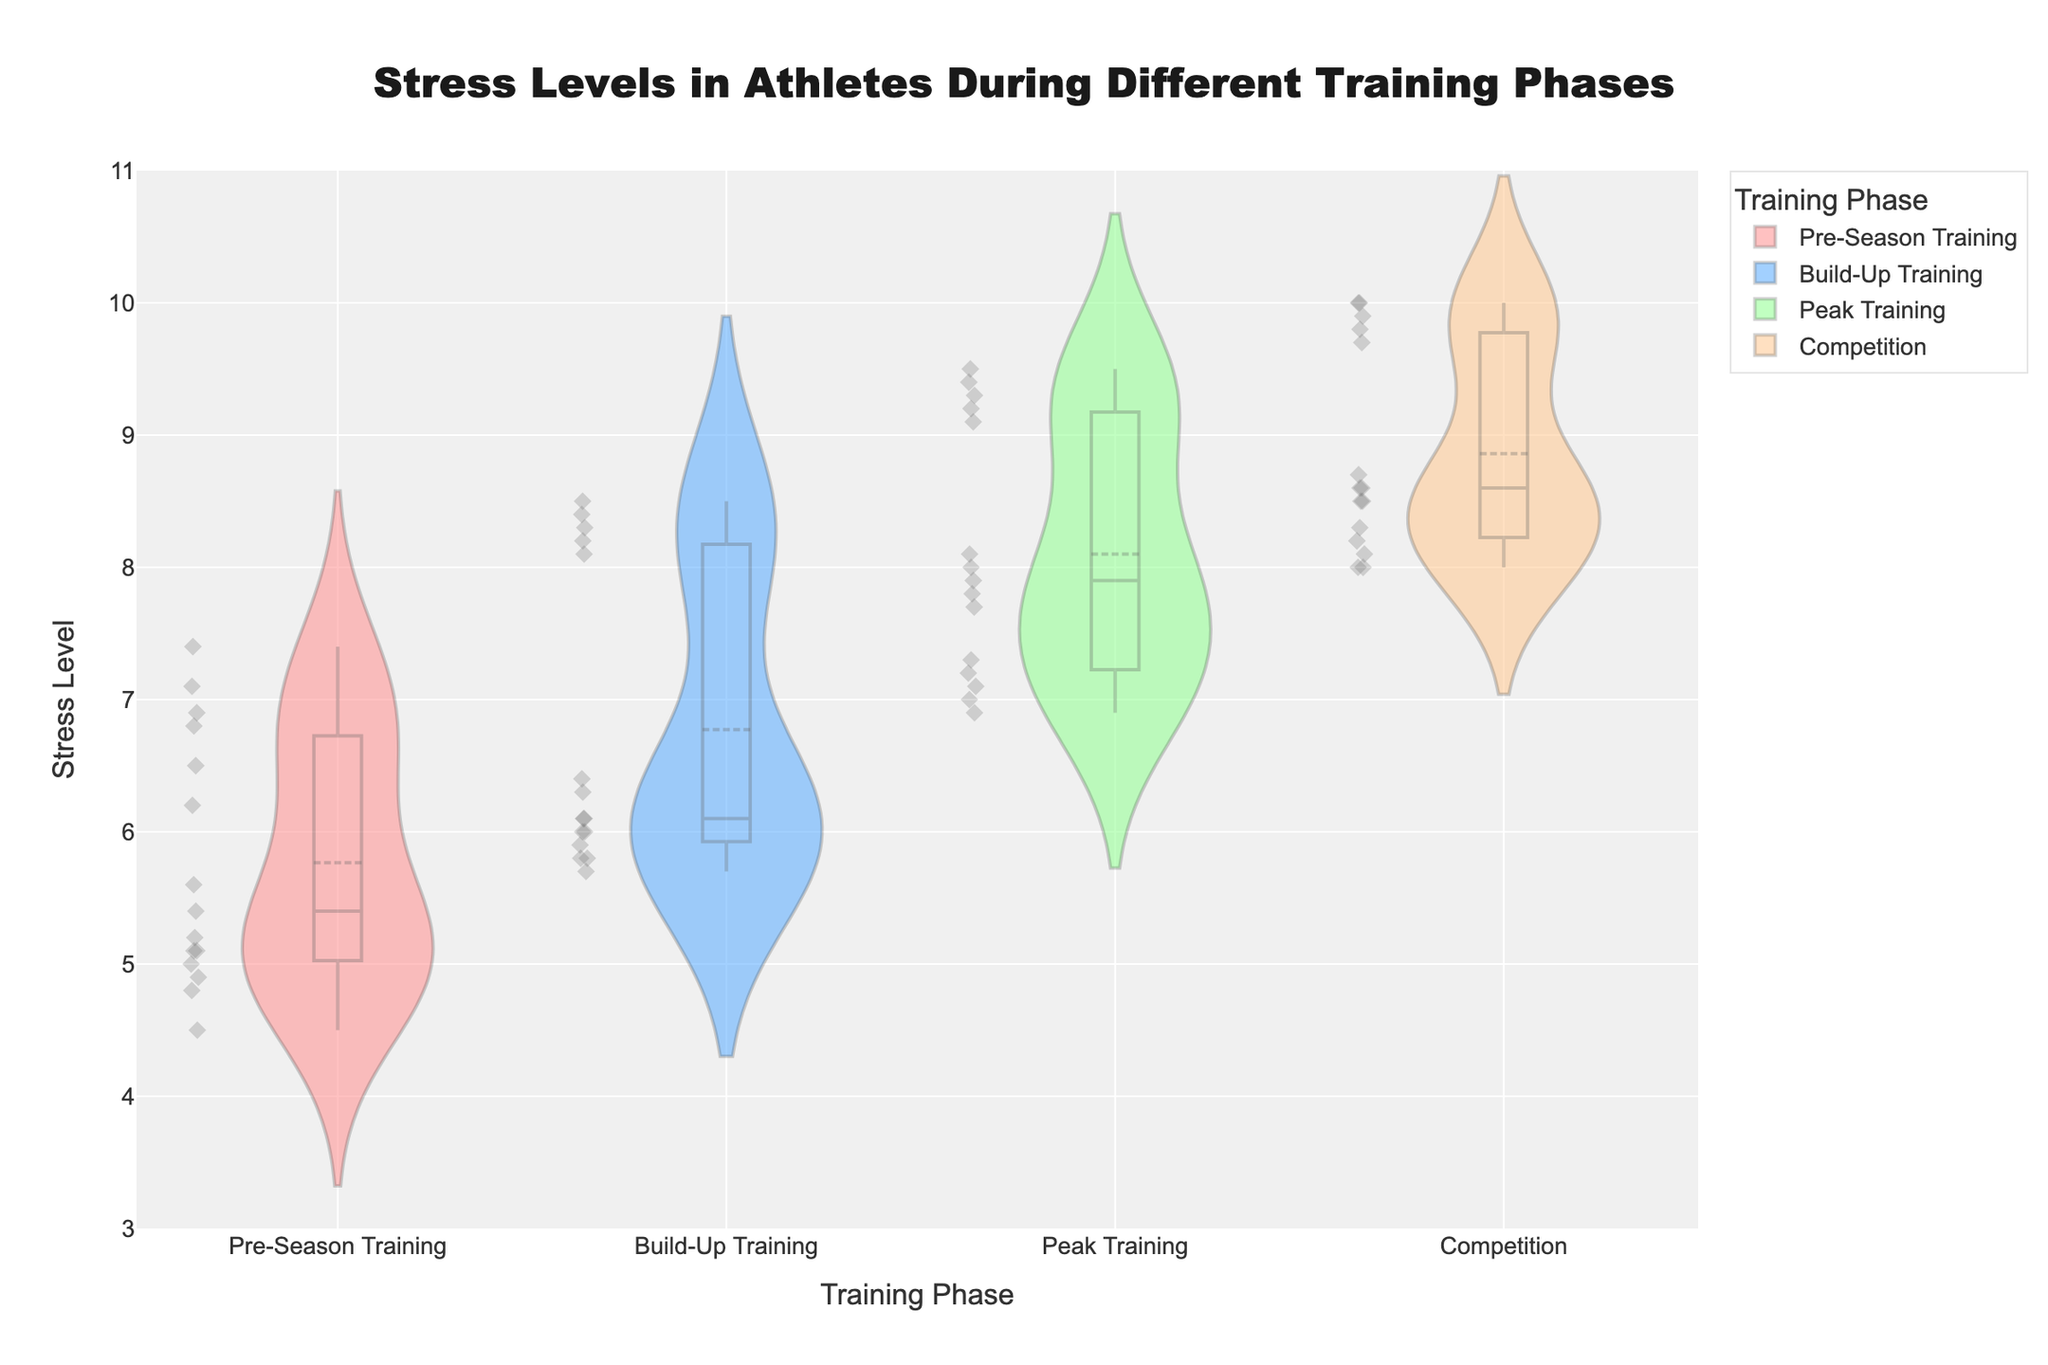What are the phases of training shown in the title of the plot? The title of the plot lists "Stress Levels in Athletes During Different Training Phases". The phases of training on the x-axis of the plot are "Pre-Season Training", "Build-Up Training", "Peak Training", and "Competition".
Answer: Pre-Season Training, Build-Up Training, Peak Training, Competition What is the maximum stress level for James Duncan during the Competition phase? Look at the violin plot for James Duncan during the Competition phase, which includes both the distribution and individual points. The highest data point is at 10.0.
Answer: 10.0 Which phase has the lowest median stress level for Maria Stepanova? Examine the box plots within each violin plot for Maria Stepanova across all phases. The box plot indicates the median as a line. The lowest median is seen in "Pre-Season Training".
Answer: Pre-Season Training Which phase shows the highest average stress level for Lily Chen? Observe the meanline (a point typically marked or referenced in the middle of the box) within the violin plots for Lily Chen. The "Competition" phase has the highest mean stress level, indicated by the average line in the box plot.
Answer: Competition How does the distribution of stress levels compare between Peak Training and Build-Up Training for James Duncan? Compare the widths and shapes of the violin plots for these phases. The distribution for Peak Training is narrower with higher stress levels compared to the wider distribution in Build-Up Training, indicating more consistent and higher stress levels during Peak Training.
Answer: Higher and narrower in Peak Training What is the interquartile range (IQR) for Lily Chen's stress levels during Peak Training? The IQR is the box length in the box plot, from the lower quartile (25th percentile) to the upper quartile (75th percentile). For Lily Chen, the lower quartile is at 7.0 and the upper quartile is at 7.2. The IQR is thus 7.2 - 7.0.
Answer: 0.2 Which athlete shows the most significant increase in stress levels from Pre-Season Training to Competition phase? Compare the stress levels for each athlete across these two phases. James Duncan shows the most significant increase, going from around 6.8-7.4 in Pre-Season Training to near 10.0 in Competition.
Answer: James Duncan Based on the plots, during which phase is Maria Stepanova's stress level the most consistent? Consistency can be judged by the narrowness of the distribution in the violin plot and the shortness of the box plot. The most consistent stress level for Maria Stepanova is in the "Peak Training" phase, where the violin width is narrow and box plot is tight.
Answer: Peak Training 